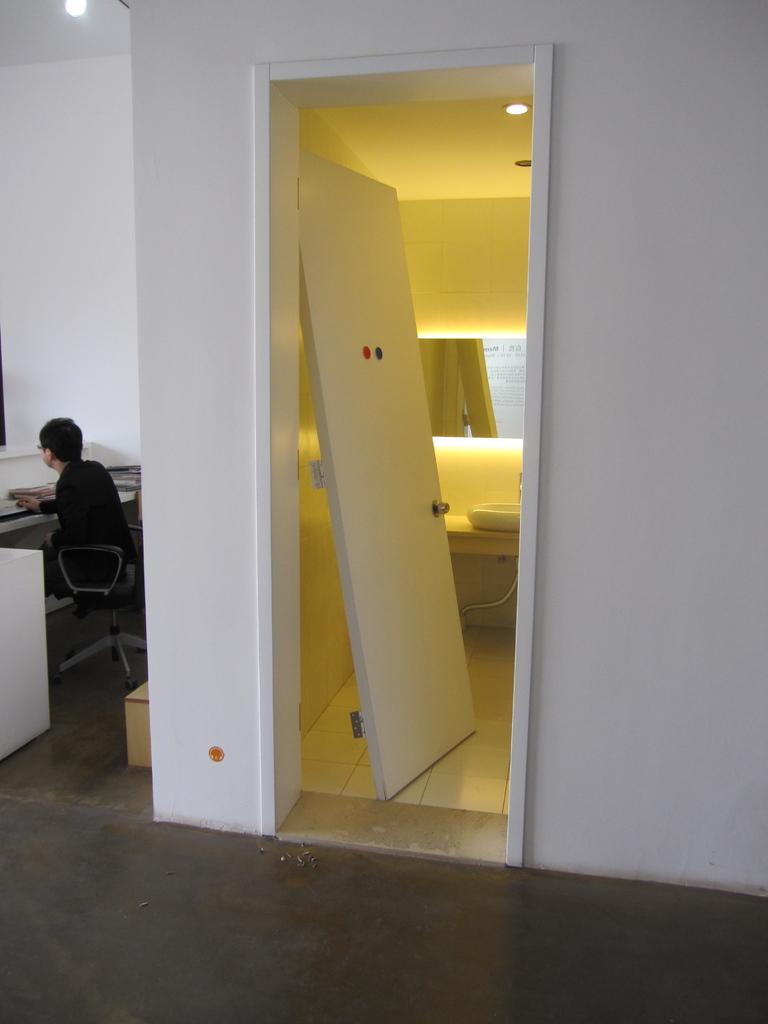What is the person in the image doing? The person is sitting in the image. What is the person wearing? The person is wearing clothes. What is visible beneath the person? The floor is visible in the image. What architectural feature can be seen in the image? There is a door in the image. What else is visible in the background of the image? The wall is visible in the image. What type of stocking is the person wearing in the image? There is no mention of stockings in the image, so it cannot be determined what type the person might be wearing. 